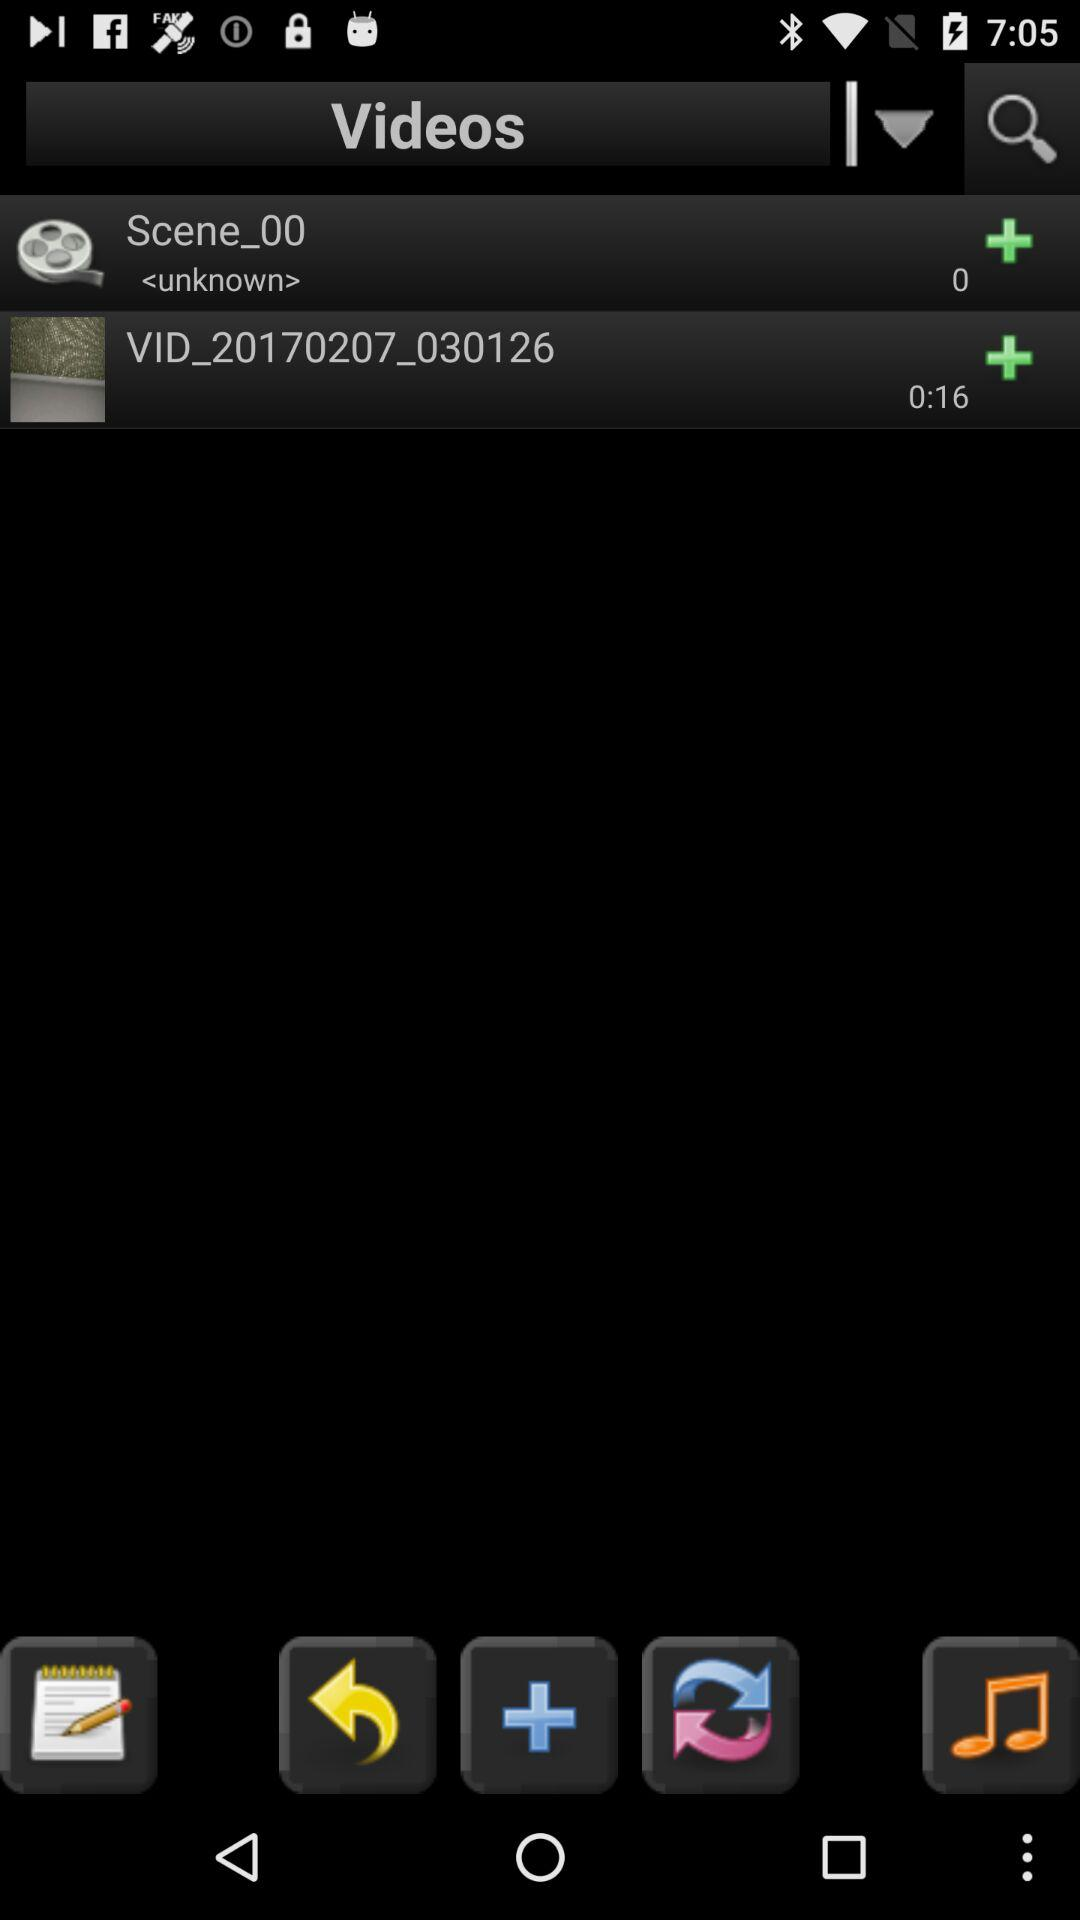What's the duration of the video? The duration of the video is 16 seconds. 